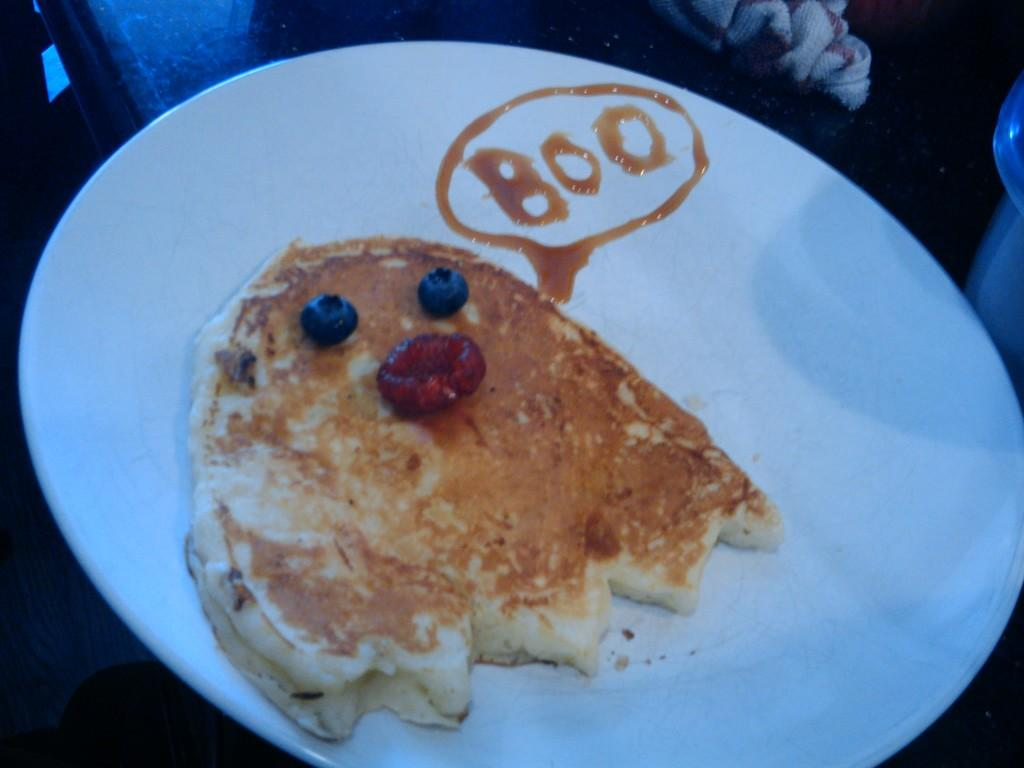What is on the plate that is visible in the image? There is a pancake on the plate in the image. What else is on the plate besides the pancake? There are cherries on the plate. Where is the plate located in the image? The plate is placed on a table. How many fingers can be seen playing the guitar in the image? There is no guitar or fingers playing a guitar in the image. 